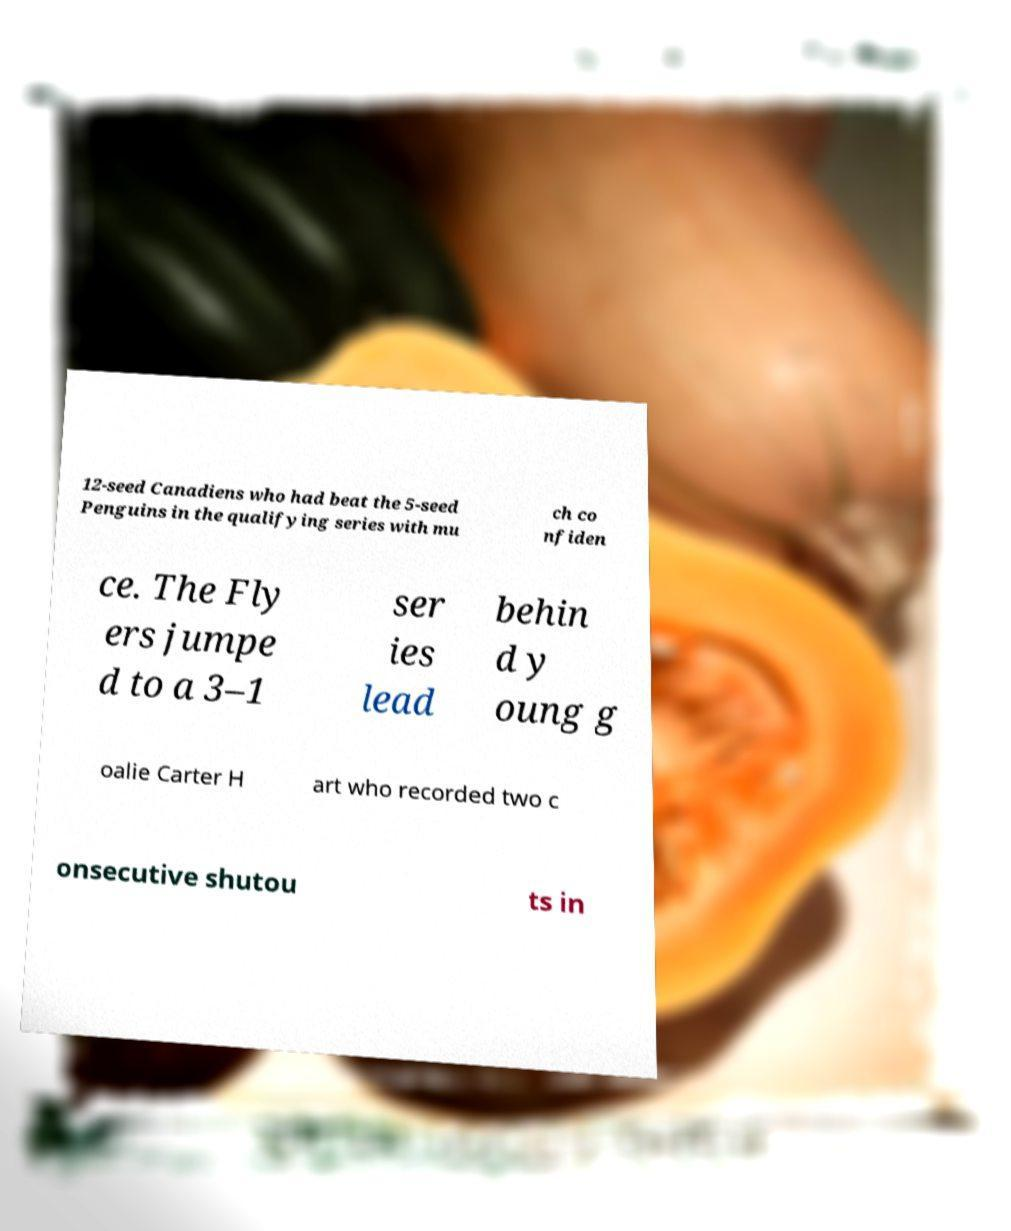There's text embedded in this image that I need extracted. Can you transcribe it verbatim? 12-seed Canadiens who had beat the 5-seed Penguins in the qualifying series with mu ch co nfiden ce. The Fly ers jumpe d to a 3–1 ser ies lead behin d y oung g oalie Carter H art who recorded two c onsecutive shutou ts in 